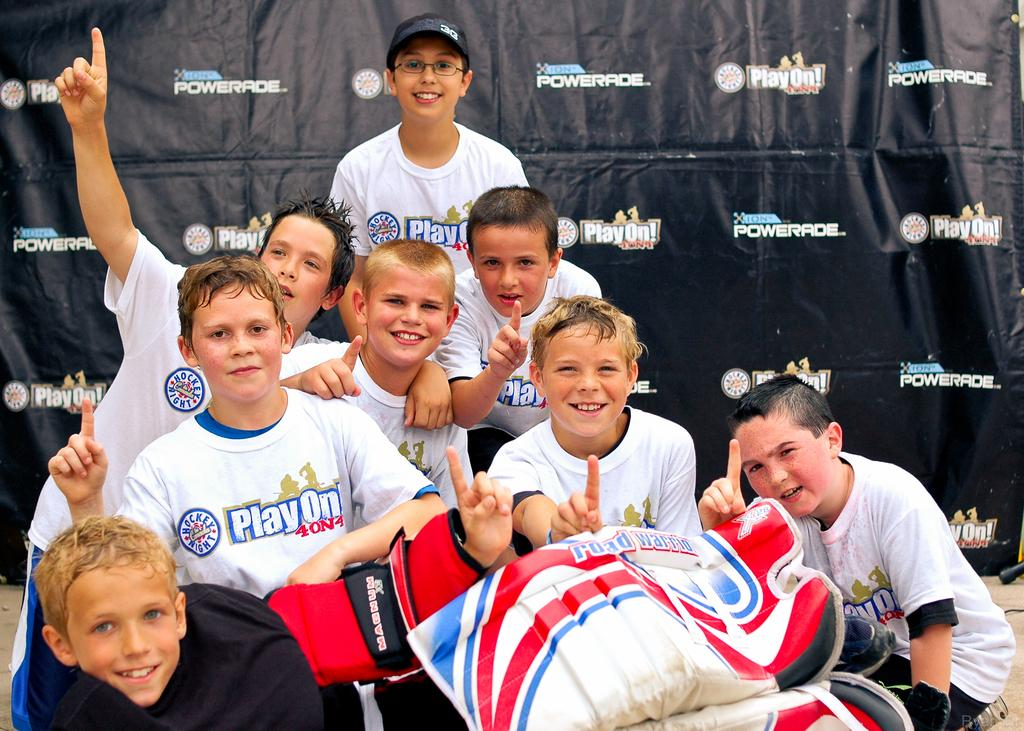Provide a one-sentence caption for the provided image. Children wearing white shirts that say Playon behind a black banner. 